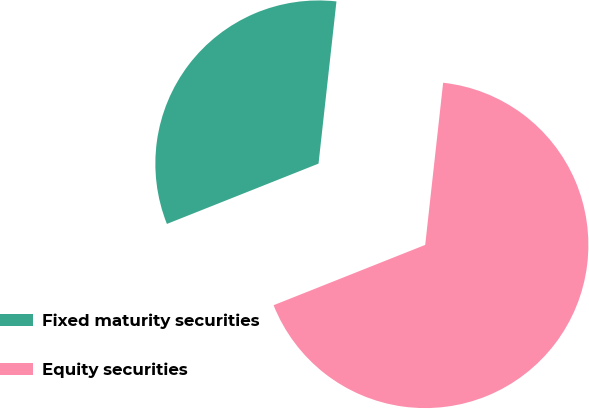Convert chart to OTSL. <chart><loc_0><loc_0><loc_500><loc_500><pie_chart><fcel>Fixed maturity securities<fcel>Equity securities<nl><fcel>32.78%<fcel>67.22%<nl></chart> 